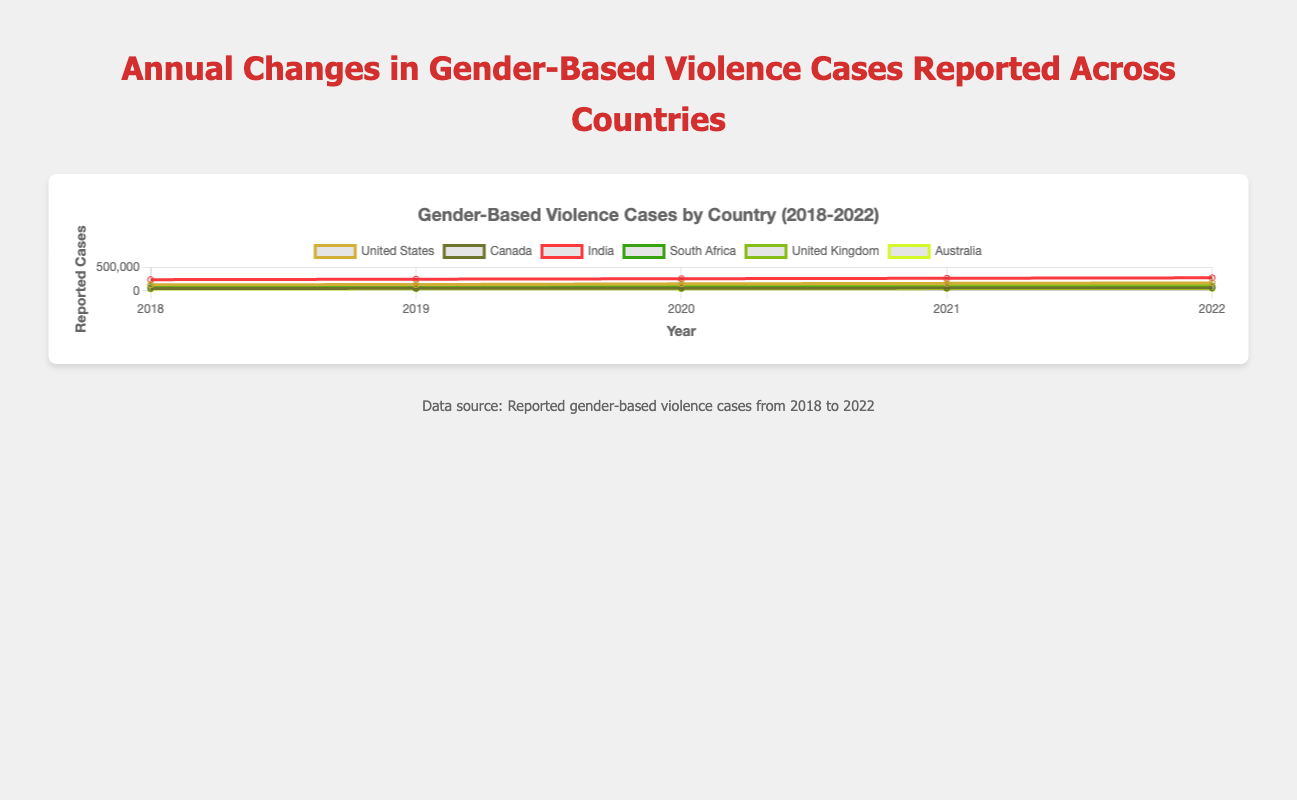What is the overall trend in gender-based violence cases in the United States from 2018 to 2022? The line representing the United States shows a steady increase in reported cases each year from 130,000 in 2018 to 170,000 in 2022.
Answer: Increasing Which country had the highest reported number of gender-based violence cases in 2022? Comparing the data points for each country in 2022 shows that India had the highest number of reported cases with 280,000.
Answer: India How did the reported cases in Canada change from 2019 to 2020? For Canada, the reported cases in 2019 were 53,000, and in 2020 they were 56,000. The difference is obtained by subtracting 53,000 from 56,000, resulting in an increase of 3,000 cases.
Answer: Increased by 3,000 Which country experienced the smallest increase in reported cases from 2018 to 2022? To find this, calculate the difference in reported cases for each country between 2018 and 2022: 
- United States: 170,000 - 130,000 = 40,000
- Canada: 60,000 - 50,000 = 10,000
- India: 280,000 - 240,000 = 40,000
- South Africa: 68,000 - 60,000 = 8,000
- United Kingdom: 103,000 - 95,000 = 8,000
- Australia: 49,000 - 40,000 = 9,000
South Africa and the United Kingdom both had the smallest increase with 8,000 cases.
Answer: South Africa and United Kingdom What is the average number of reported cases across all countries in 2020? Sum up the reported cases for each country in 2020 and divide by the number of countries:
(150,000 + 56,000 + 260,000 + 64,000 + 99,000 + 45,000) / 6 = 674,000 / 6 ≈ 112,333
Answer: 112,333 Which country saw the greatest percentage increase in reported cases from 2018 to 2022? Calculate the percentage increase for each country using the formula: (2022 cases - 2018 cases) / 2018 cases * 100
- United States: (170,000 - 130,000) / 130,000 * 100 ≈ 30.77%
- Canada: (60,000 - 50,000) / 50,000 * 100 = 20%
- India: (280,000 - 240,000) / 240,000 * 100 ≈ 16.67%
- South Africa: (68,000 - 60,000) / 60,000 * 100 ≈ 13.33%
- United Kingdom: (103,000 - 95,000) / 95,000 * 100 ≈ 8.42%
- Australia: (49,000 - 40,000) / 40,000 * 100 ≈ 22.5%
The United States saw the greatest percentage increase at approximately 30.77%.
Answer: United States Between which two consecutive years did Australia see the largest increase in reported cases? Checking the differences year by year:
- 2019-2018: 42,000 - 40,000 = 2,000
- 2020-2019: 45,000 - 42,000 = 3,000
- 2021-2020: 47,000 - 45,000 = 2,000
- 2022-2021: 49,000 - 47,000 = 2,000
The largest increase of 3,000 cases occurred between 2019 and 2020.
Answer: 2019 to 2020 